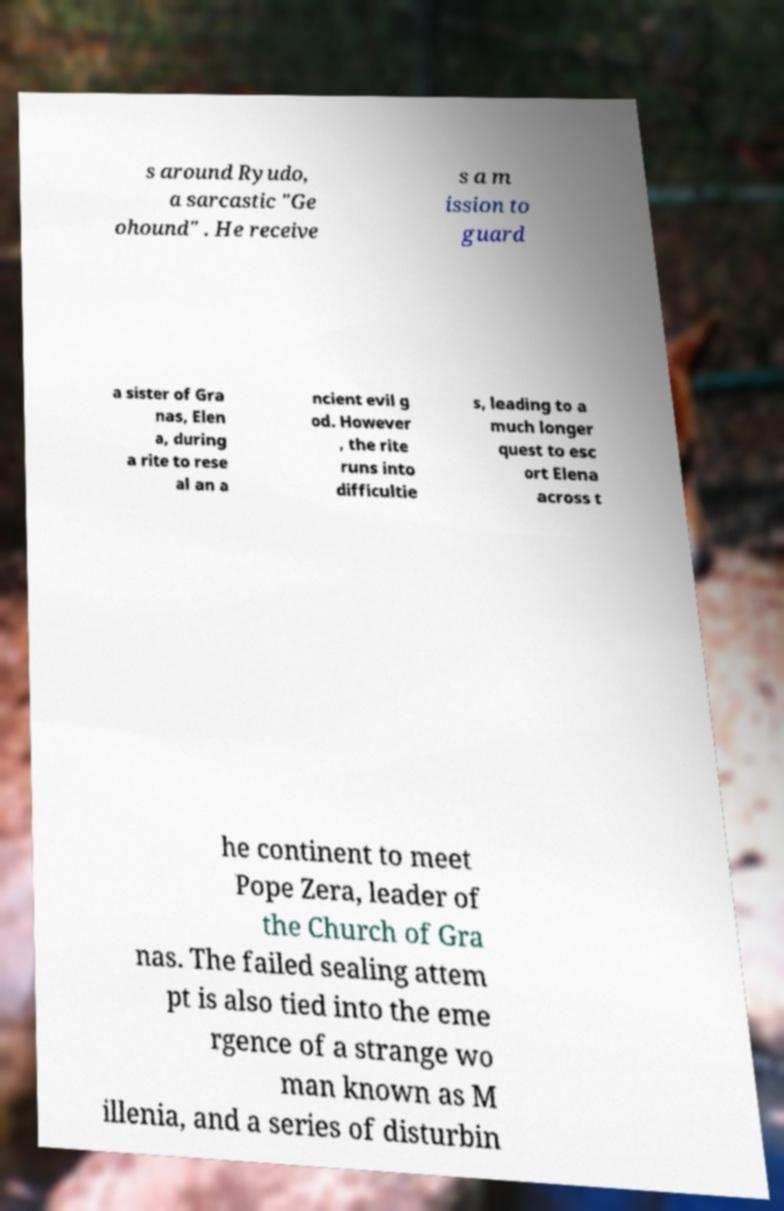Can you accurately transcribe the text from the provided image for me? s around Ryudo, a sarcastic "Ge ohound" . He receive s a m ission to guard a sister of Gra nas, Elen a, during a rite to rese al an a ncient evil g od. However , the rite runs into difficultie s, leading to a much longer quest to esc ort Elena across t he continent to meet Pope Zera, leader of the Church of Gra nas. The failed sealing attem pt is also tied into the eme rgence of a strange wo man known as M illenia, and a series of disturbin 